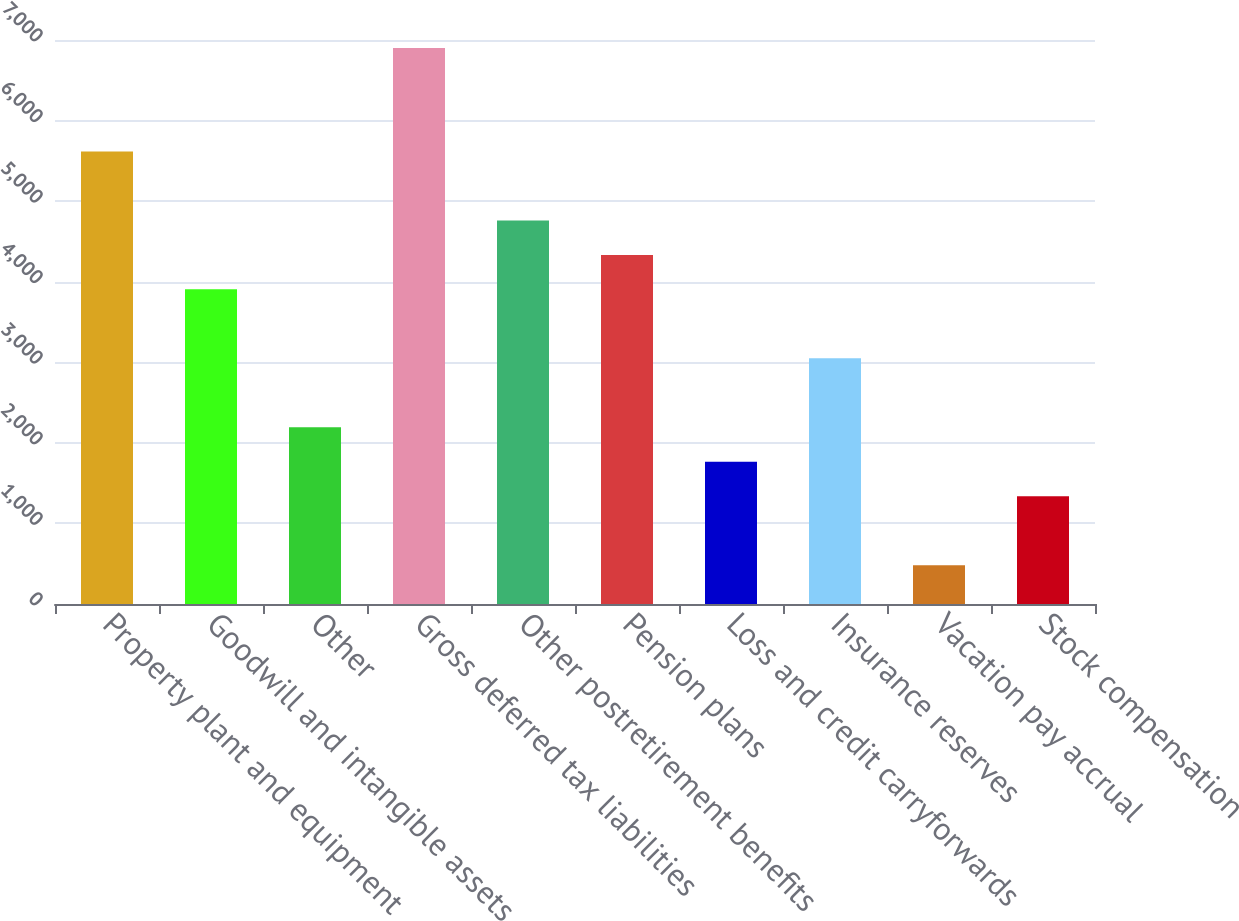Convert chart. <chart><loc_0><loc_0><loc_500><loc_500><bar_chart><fcel>Property plant and equipment<fcel>Goodwill and intangible assets<fcel>Other<fcel>Gross deferred tax liabilities<fcel>Other postretirement benefits<fcel>Pension plans<fcel>Loss and credit carryforwards<fcel>Insurance reserves<fcel>Vacation pay accrual<fcel>Stock compensation<nl><fcel>5616.7<fcel>3905.1<fcel>2193.5<fcel>6900.4<fcel>4760.9<fcel>4333<fcel>1765.6<fcel>3049.3<fcel>481.9<fcel>1337.7<nl></chart> 